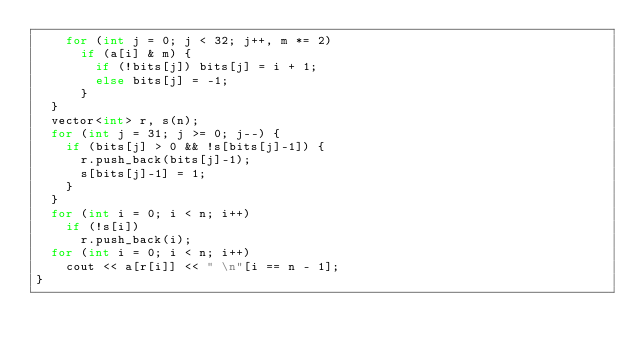<code> <loc_0><loc_0><loc_500><loc_500><_C++_>    for (int j = 0; j < 32; j++, m *= 2)
      if (a[i] & m) {
        if (!bits[j]) bits[j] = i + 1;
        else bits[j] = -1;
      }
  }
  vector<int> r, s(n);
  for (int j = 31; j >= 0; j--) {
    if (bits[j] > 0 && !s[bits[j]-1]) {
      r.push_back(bits[j]-1);
      s[bits[j]-1] = 1;
    }
  }
  for (int i = 0; i < n; i++)
    if (!s[i])
      r.push_back(i);
  for (int i = 0; i < n; i++)
    cout << a[r[i]] << " \n"[i == n - 1];
}
</code> 